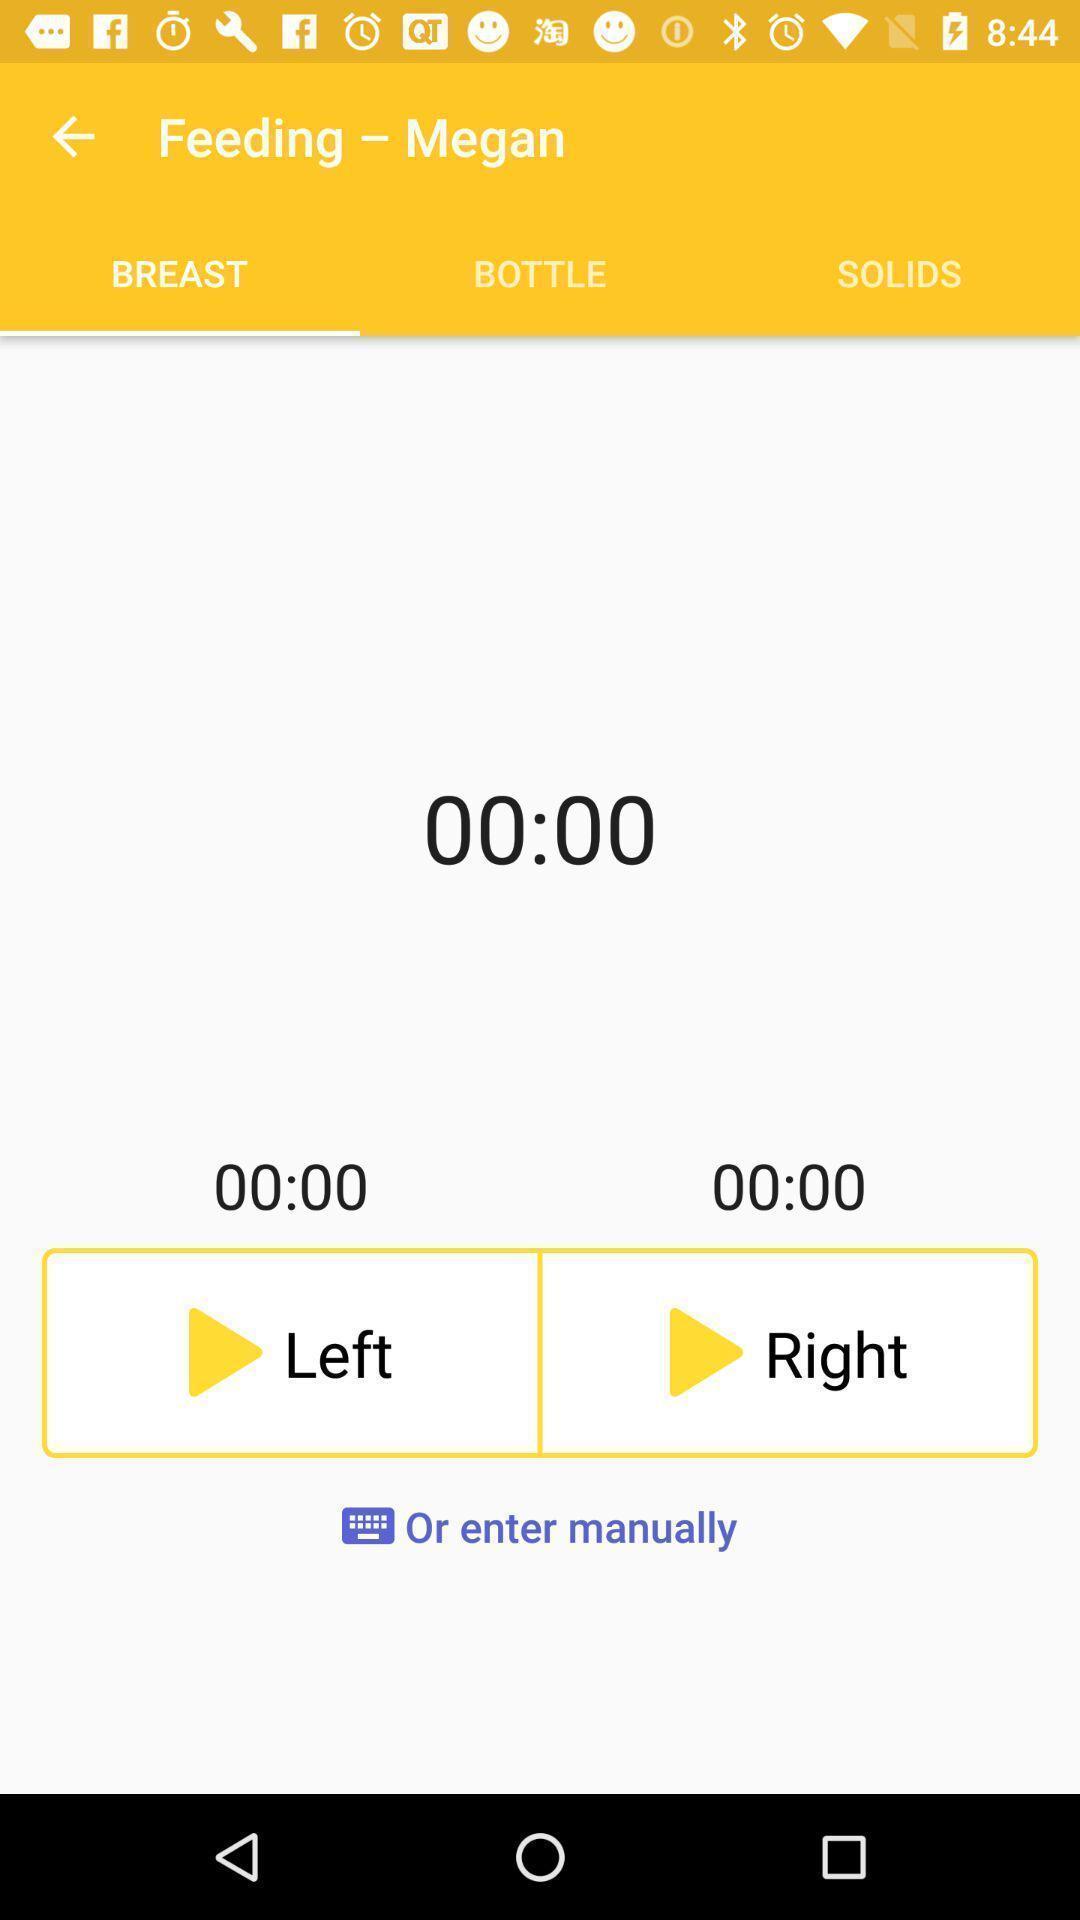What can you discern from this picture? Page displaying tracking of breast feeding. 